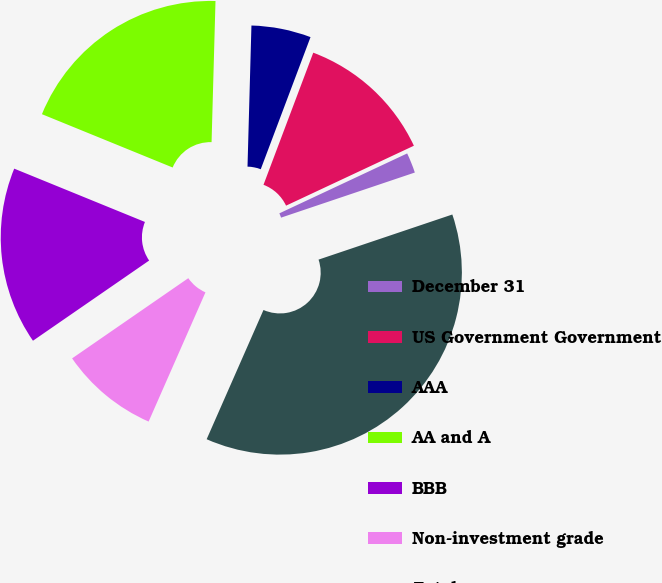Convert chart. <chart><loc_0><loc_0><loc_500><loc_500><pie_chart><fcel>December 31<fcel>US Government Government<fcel>AAA<fcel>AA and A<fcel>BBB<fcel>Non-investment grade<fcel>Total<nl><fcel>1.8%<fcel>12.29%<fcel>5.29%<fcel>19.28%<fcel>15.78%<fcel>8.79%<fcel>36.77%<nl></chart> 